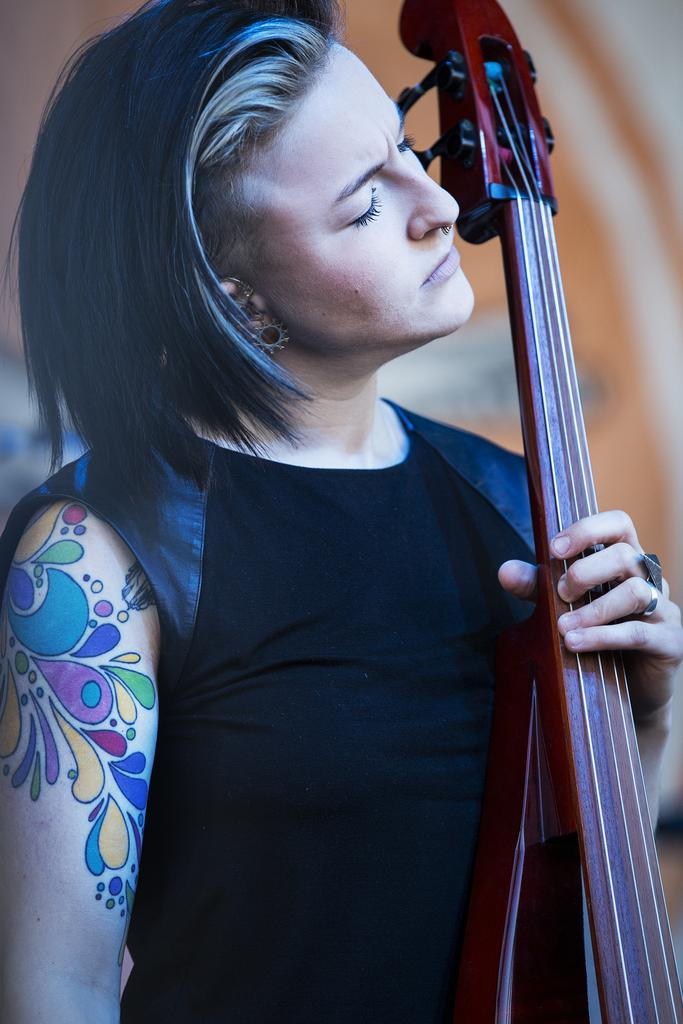Who is the main subject in the image? There is a woman in the image. What is the woman wearing? The woman is wearing a black dress. What is the woman holding in the image? The woman is holding a violin. Can you describe any additional features of the woman? The woman has a tattoo on her hand. What yard tool is the woman using to make a discovery in the image? There is no yard tool or discovery present in the image; it features a woman holding a violin and wearing a black dress with a tattoo on her hand. 